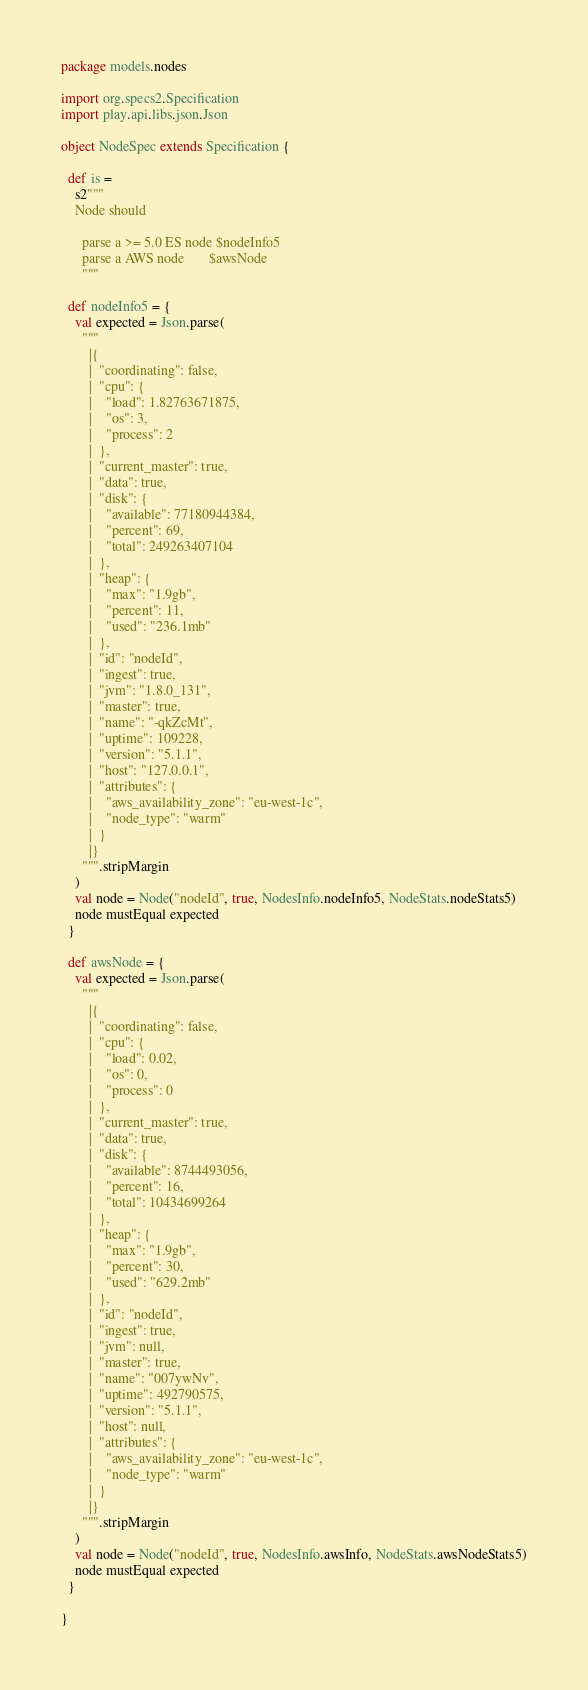Convert code to text. <code><loc_0><loc_0><loc_500><loc_500><_Scala_>package models.nodes

import org.specs2.Specification
import play.api.libs.json.Json

object NodeSpec extends Specification {

  def is =
    s2"""
    Node should

      parse a >= 5.0 ES node $nodeInfo5
      parse a AWS node       $awsNode
      """

  def nodeInfo5 = {
    val expected = Json.parse(
      """
        |{
        |  "coordinating": false,
        |  "cpu": {
        |    "load": 1.82763671875,
        |    "os": 3,
        |    "process": 2
        |  },
        |  "current_master": true,
        |  "data": true,
        |  "disk": {
        |    "available": 77180944384,
        |    "percent": 69,
        |    "total": 249263407104
        |  },
        |  "heap": {
        |    "max": "1.9gb",
        |    "percent": 11,
        |    "used": "236.1mb"
        |  },
        |  "id": "nodeId",
        |  "ingest": true,
        |  "jvm": "1.8.0_131",
        |  "master": true,
        |  "name": "-qkZcMt",
        |  "uptime": 109228,
        |  "version": "5.1.1",
        |  "host": "127.0.0.1",
        |  "attributes": {
        |    "aws_availability_zone": "eu-west-1c",
        |    "node_type": "warm"
        |  }
        |}
      """.stripMargin
    )
    val node = Node("nodeId", true, NodesInfo.nodeInfo5, NodeStats.nodeStats5)
    node mustEqual expected
  }

  def awsNode = {
    val expected = Json.parse(
      """
        |{
        |  "coordinating": false,
        |  "cpu": {
        |    "load": 0.02,
        |    "os": 0,
        |    "process": 0
        |  },
        |  "current_master": true,
        |  "data": true,
        |  "disk": {
        |    "available": 8744493056,
        |    "percent": 16,
        |    "total": 10434699264
        |  },
        |  "heap": {
        |    "max": "1.9gb",
        |    "percent": 30,
        |    "used": "629.2mb"
        |  },
        |  "id": "nodeId",
        |  "ingest": true,
        |  "jvm": null,
        |  "master": true,
        |  "name": "007ywNv",
        |  "uptime": 492790575,
        |  "version": "5.1.1",
        |  "host": null,
        |  "attributes": {
        |    "aws_availability_zone": "eu-west-1c",
        |    "node_type": "warm"
        |  }
        |}
      """.stripMargin
    )
    val node = Node("nodeId", true, NodesInfo.awsInfo, NodeStats.awsNodeStats5)
    node mustEqual expected
  }

}
</code> 